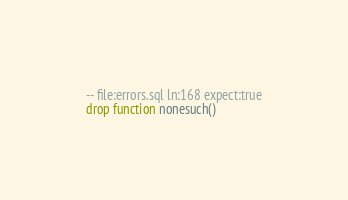<code> <loc_0><loc_0><loc_500><loc_500><_SQL_>-- file:errors.sql ln:168 expect:true
drop function nonesuch()
</code> 